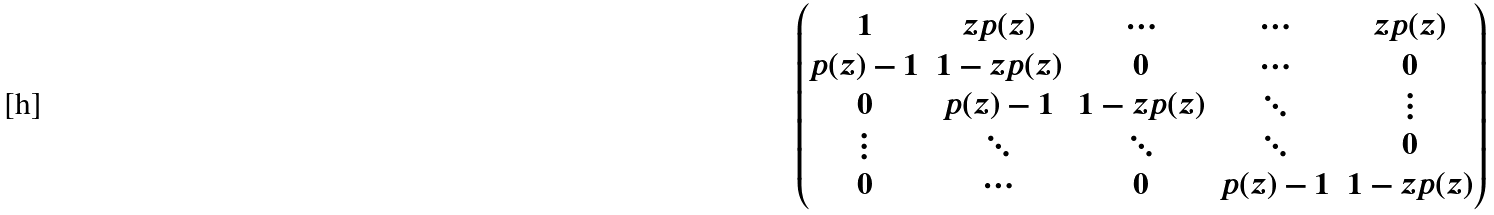Convert formula to latex. <formula><loc_0><loc_0><loc_500><loc_500>\begin{pmatrix} 1 & z p ( z ) & \cdots & \cdots & z p ( z ) \\ p ( z ) - 1 & 1 - z p ( z ) & 0 & \cdots & 0 \\ 0 & p ( z ) - 1 & 1 - z p ( z ) & \ddots & \vdots \\ \vdots & \ddots & \ddots & \ddots & 0 \\ 0 & \cdots & 0 & p ( z ) - 1 & 1 - z p ( z ) \end{pmatrix}</formula> 